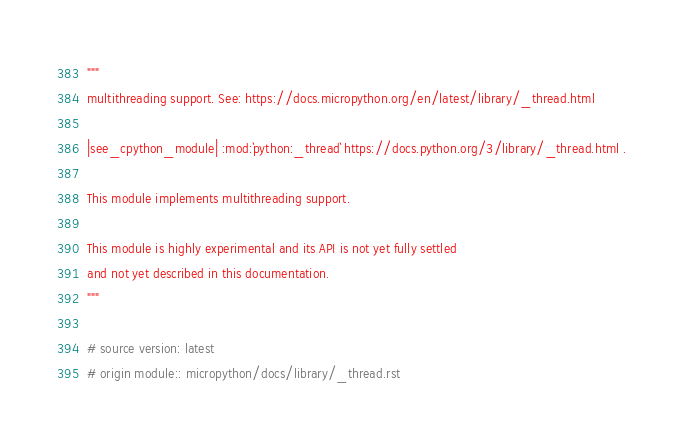<code> <loc_0><loc_0><loc_500><loc_500><_Python_>"""
multithreading support. See: https://docs.micropython.org/en/latest/library/_thread.html

|see_cpython_module| :mod:`python:_thread` https://docs.python.org/3/library/_thread.html .

This module implements multithreading support.

This module is highly experimental and its API is not yet fully settled
and not yet described in this documentation.
"""

# source version: latest
# origin module:: micropython/docs/library/_thread.rst
</code> 